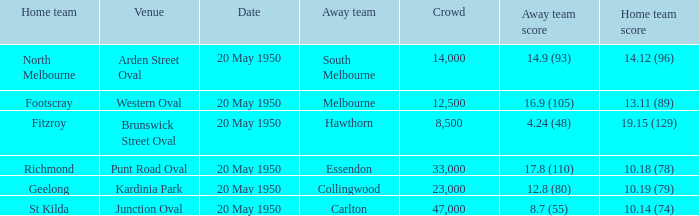What was the venue when the away team scored 14.9 (93)? Arden Street Oval. 